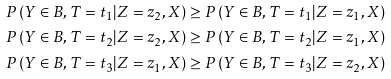Convert formula to latex. <formula><loc_0><loc_0><loc_500><loc_500>& P \left ( Y \in B , T = t _ { 1 } | Z = z _ { 2 } , X \right ) \geq P \left ( Y \in B , T = t _ { 1 } | Z = z _ { 1 } , X \right ) \\ & P \left ( Y \in B , T = t _ { 2 } | Z = z _ { 2 } , X \right ) \geq P \left ( Y \in B , T = t _ { 2 } | Z = z _ { 1 } , X \right ) \\ & P \left ( Y \in B , T = t _ { 3 } | Z = z _ { 1 } , X \right ) \geq P \left ( Y \in B , T = t _ { 3 } | Z = z _ { 2 } , X \right )</formula> 